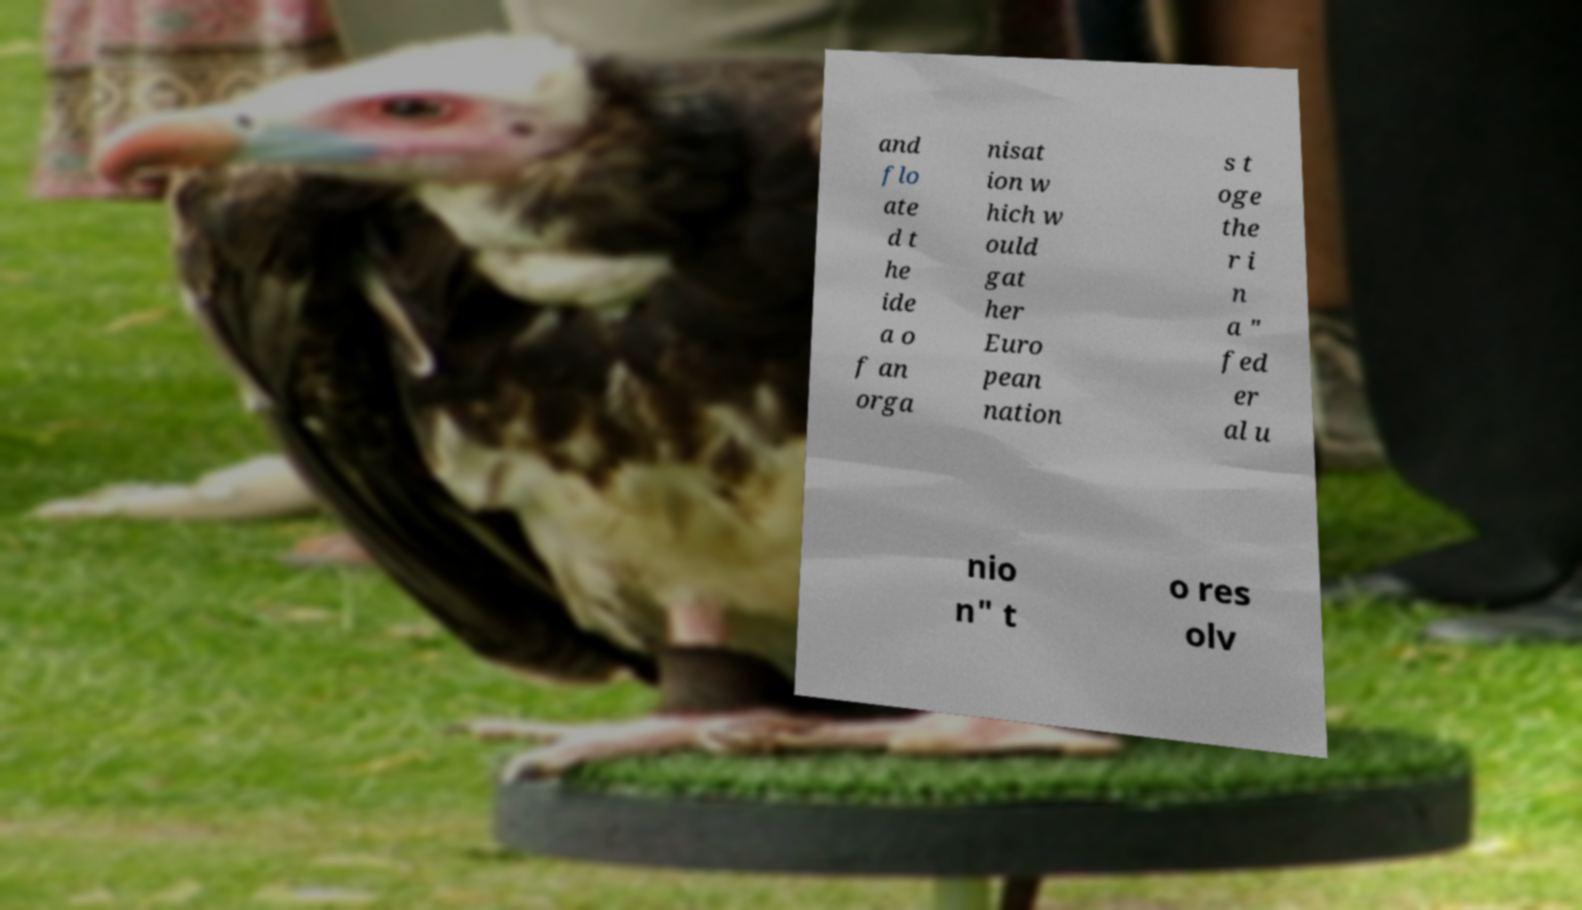Please identify and transcribe the text found in this image. and flo ate d t he ide a o f an orga nisat ion w hich w ould gat her Euro pean nation s t oge the r i n a " fed er al u nio n" t o res olv 